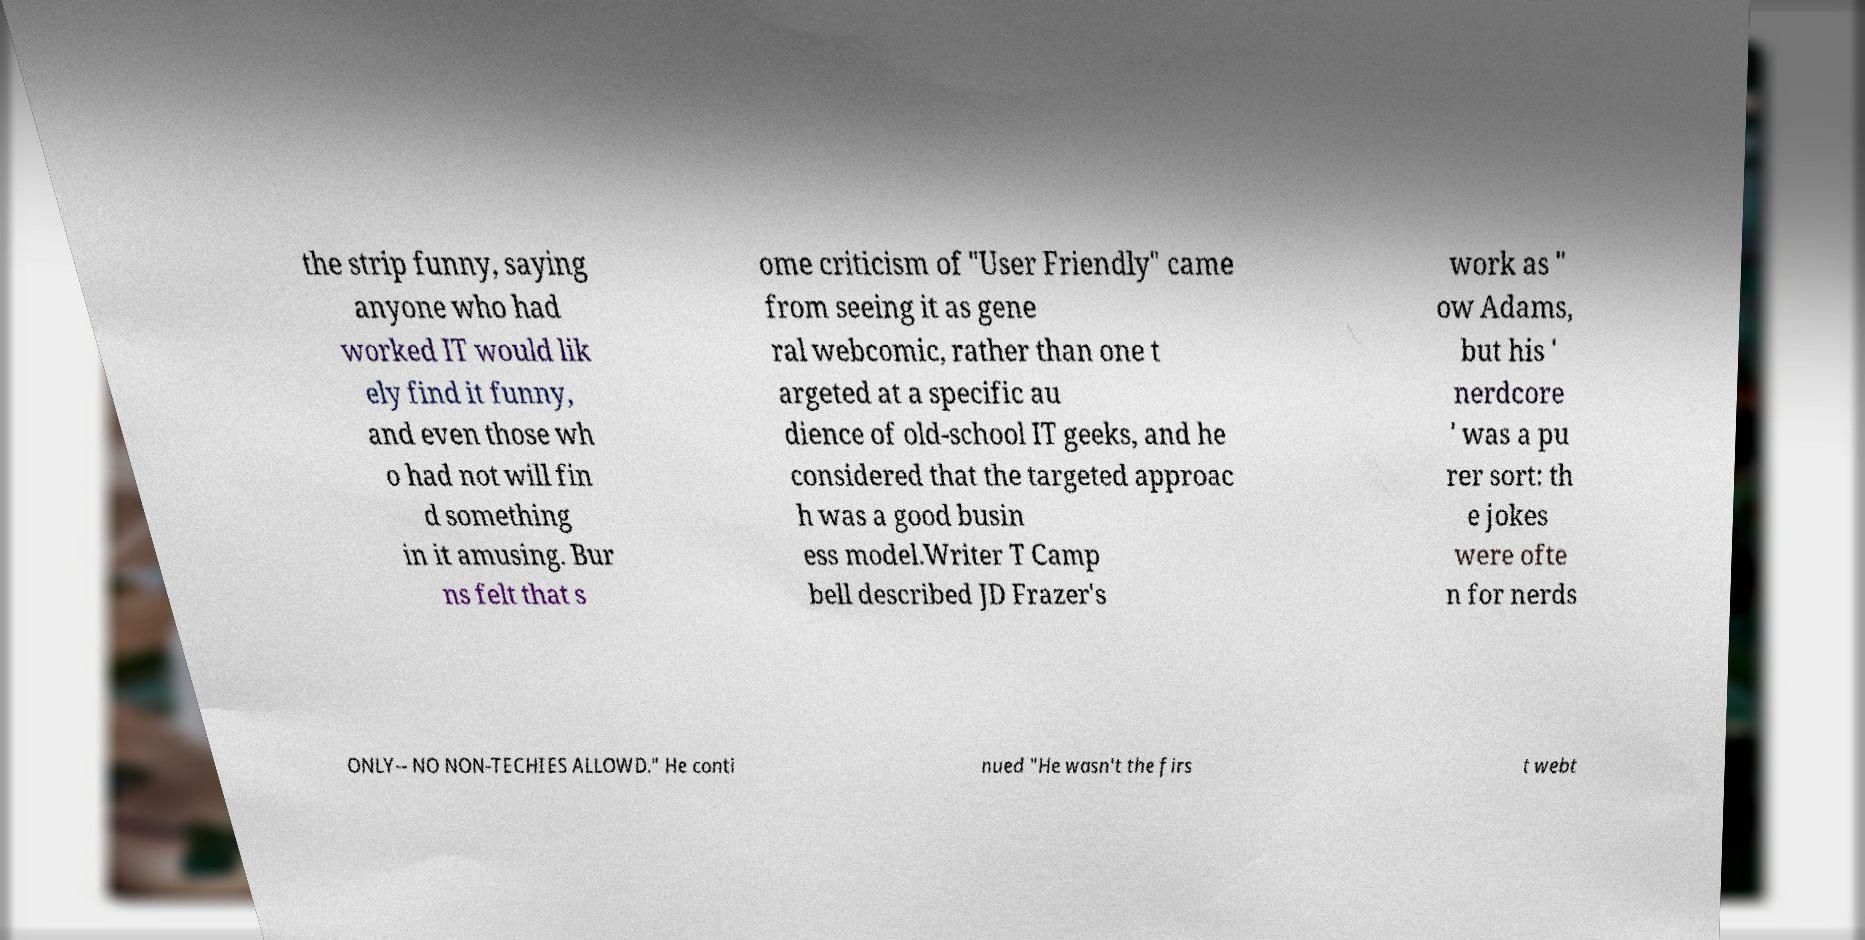Could you assist in decoding the text presented in this image and type it out clearly? the strip funny, saying anyone who had worked IT would lik ely find it funny, and even those wh o had not will fin d something in it amusing. Bur ns felt that s ome criticism of "User Friendly" came from seeing it as gene ral webcomic, rather than one t argeted at a specific au dience of old-school IT geeks, and he considered that the targeted approac h was a good busin ess model.Writer T Camp bell described JD Frazer's work as " ow Adams, but his ' nerdcore ' was a pu rer sort: th e jokes were ofte n for nerds ONLY-- NO NON-TECHIES ALLOWD." He conti nued "He wasn't the firs t webt 